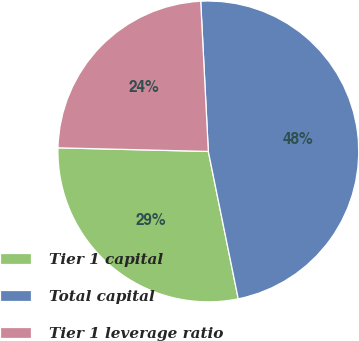Convert chart to OTSL. <chart><loc_0><loc_0><loc_500><loc_500><pie_chart><fcel>Tier 1 capital<fcel>Total capital<fcel>Tier 1 leverage ratio<nl><fcel>28.57%<fcel>47.62%<fcel>23.81%<nl></chart> 